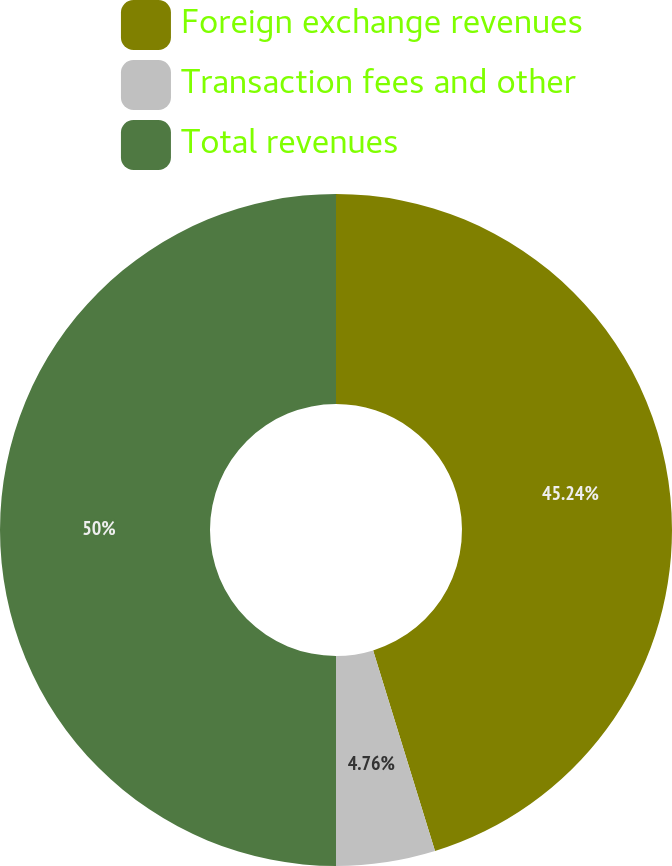<chart> <loc_0><loc_0><loc_500><loc_500><pie_chart><fcel>Foreign exchange revenues<fcel>Transaction fees and other<fcel>Total revenues<nl><fcel>45.24%<fcel>4.76%<fcel>50.0%<nl></chart> 